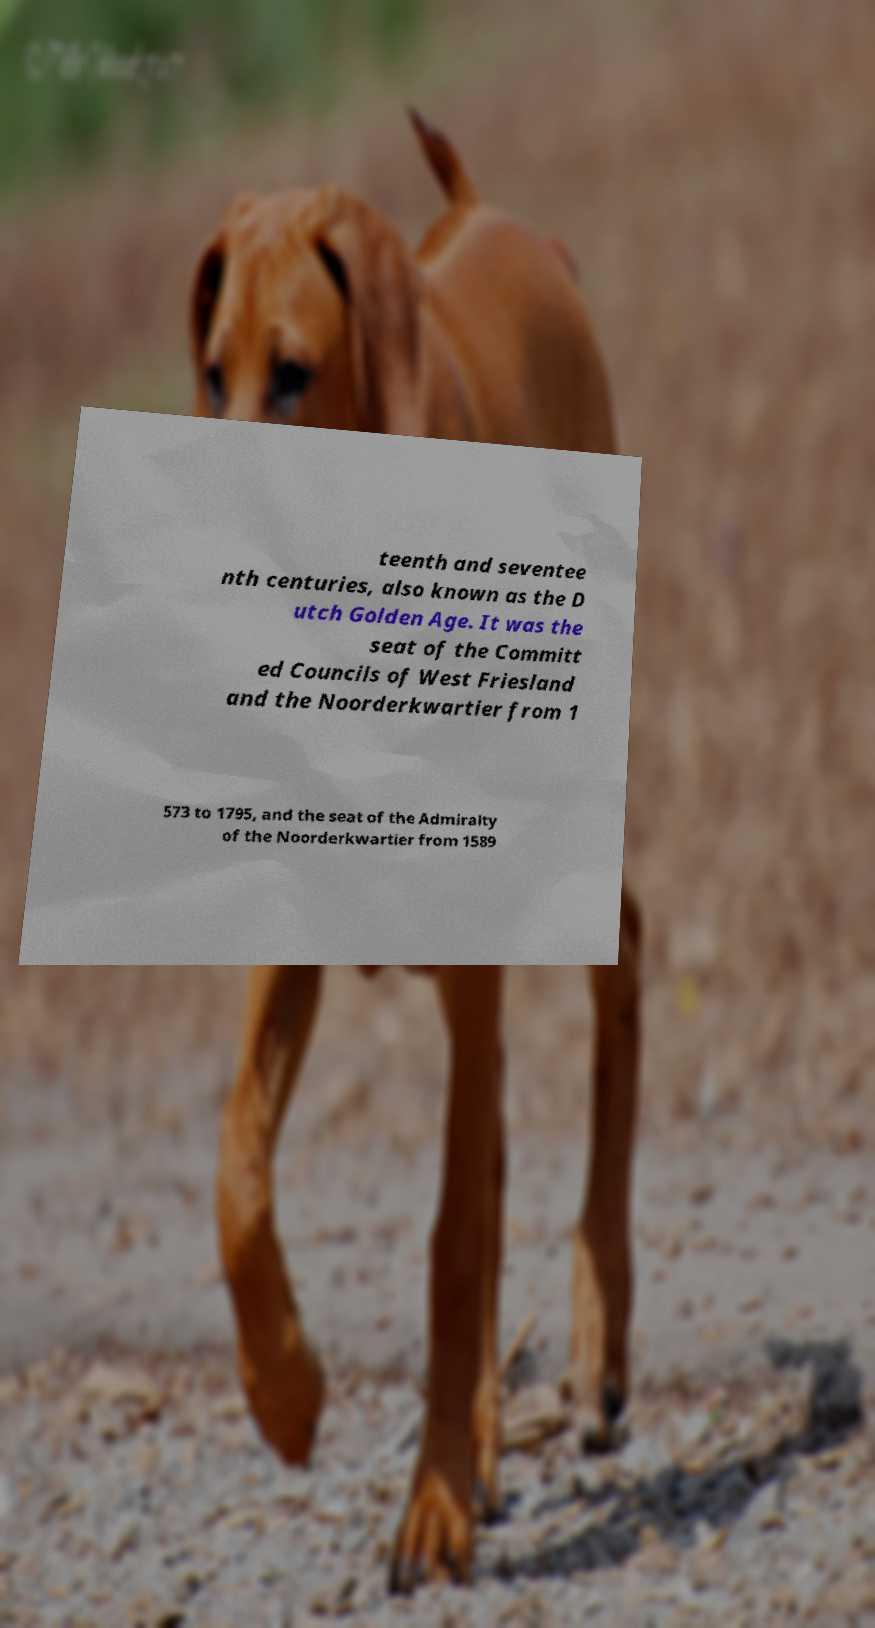Can you read and provide the text displayed in the image?This photo seems to have some interesting text. Can you extract and type it out for me? teenth and seventee nth centuries, also known as the D utch Golden Age. It was the seat of the Committ ed Councils of West Friesland and the Noorderkwartier from 1 573 to 1795, and the seat of the Admiralty of the Noorderkwartier from 1589 